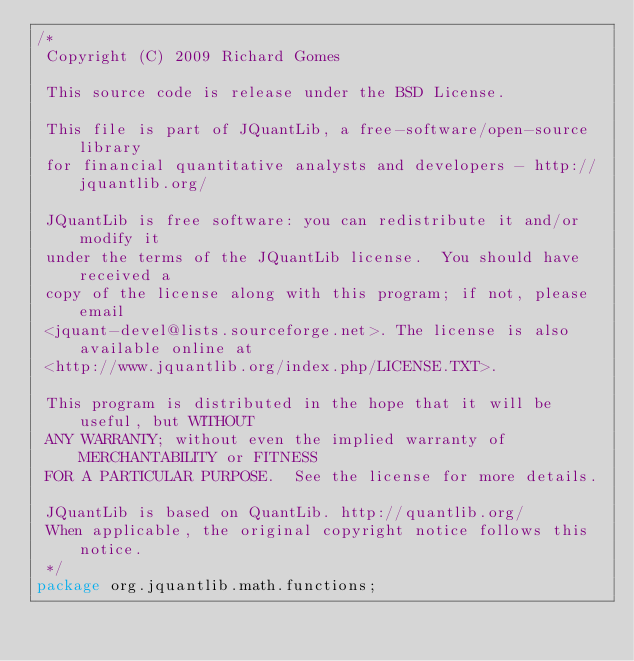<code> <loc_0><loc_0><loc_500><loc_500><_Java_>/*
 Copyright (C) 2009 Richard Gomes

 This source code is release under the BSD License.

 This file is part of JQuantLib, a free-software/open-source library
 for financial quantitative analysts and developers - http://jquantlib.org/

 JQuantLib is free software: you can redistribute it and/or modify it
 under the terms of the JQuantLib license.  You should have received a
 copy of the license along with this program; if not, please email
 <jquant-devel@lists.sourceforge.net>. The license is also available online at
 <http://www.jquantlib.org/index.php/LICENSE.TXT>.

 This program is distributed in the hope that it will be useful, but WITHOUT
 ANY WARRANTY; without even the implied warranty of MERCHANTABILITY or FITNESS
 FOR A PARTICULAR PURPOSE.  See the license for more details.

 JQuantLib is based on QuantLib. http://quantlib.org/
 When applicable, the original copyright notice follows this notice.
 */
package org.jquantlib.math.functions;
</code> 